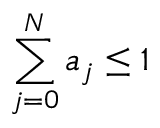Convert formula to latex. <formula><loc_0><loc_0><loc_500><loc_500>\sum _ { j = 0 } ^ { N } a _ { j } \leq 1</formula> 